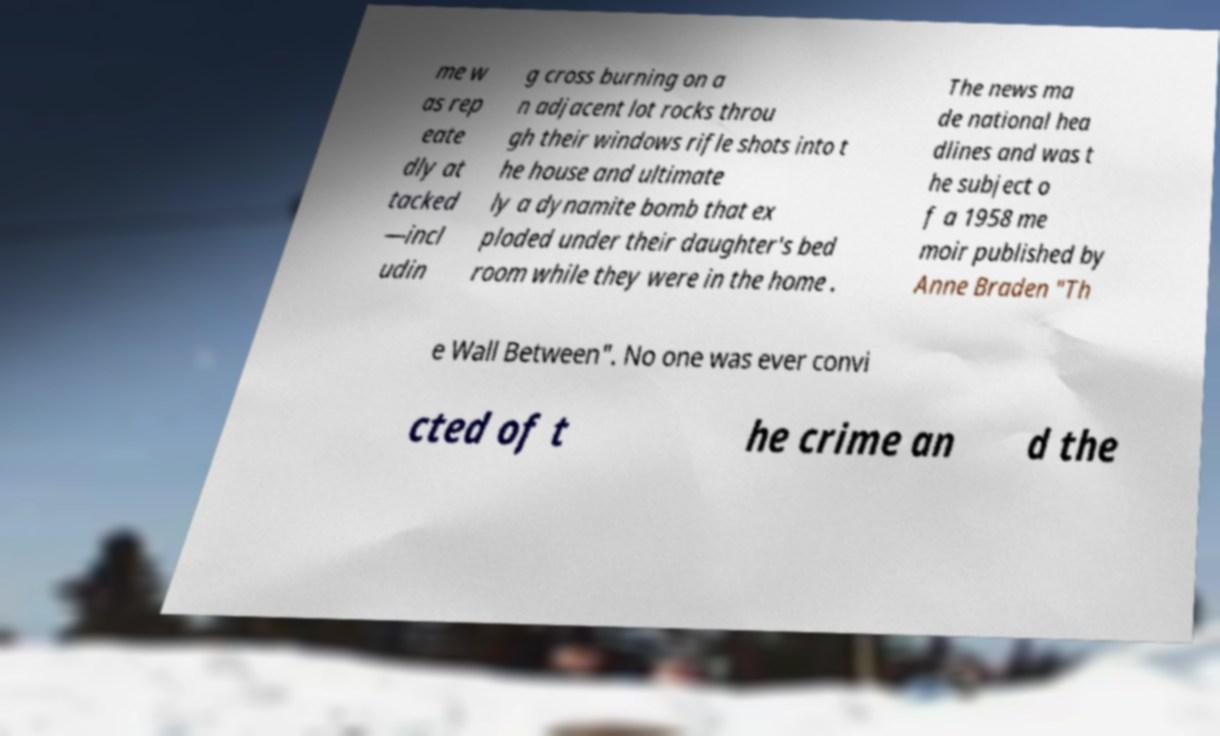There's text embedded in this image that I need extracted. Can you transcribe it verbatim? me w as rep eate dly at tacked —incl udin g cross burning on a n adjacent lot rocks throu gh their windows rifle shots into t he house and ultimate ly a dynamite bomb that ex ploded under their daughter's bed room while they were in the home . The news ma de national hea dlines and was t he subject o f a 1958 me moir published by Anne Braden "Th e Wall Between". No one was ever convi cted of t he crime an d the 